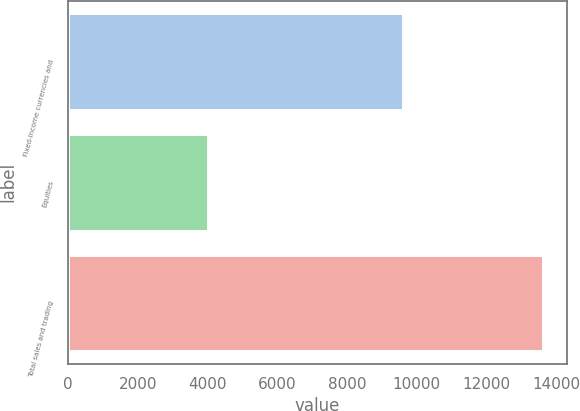<chart> <loc_0><loc_0><loc_500><loc_500><bar_chart><fcel>Fixed-income currencies and<fcel>Equities<fcel>Total sales and trading<nl><fcel>9611<fcel>4017<fcel>13628<nl></chart> 